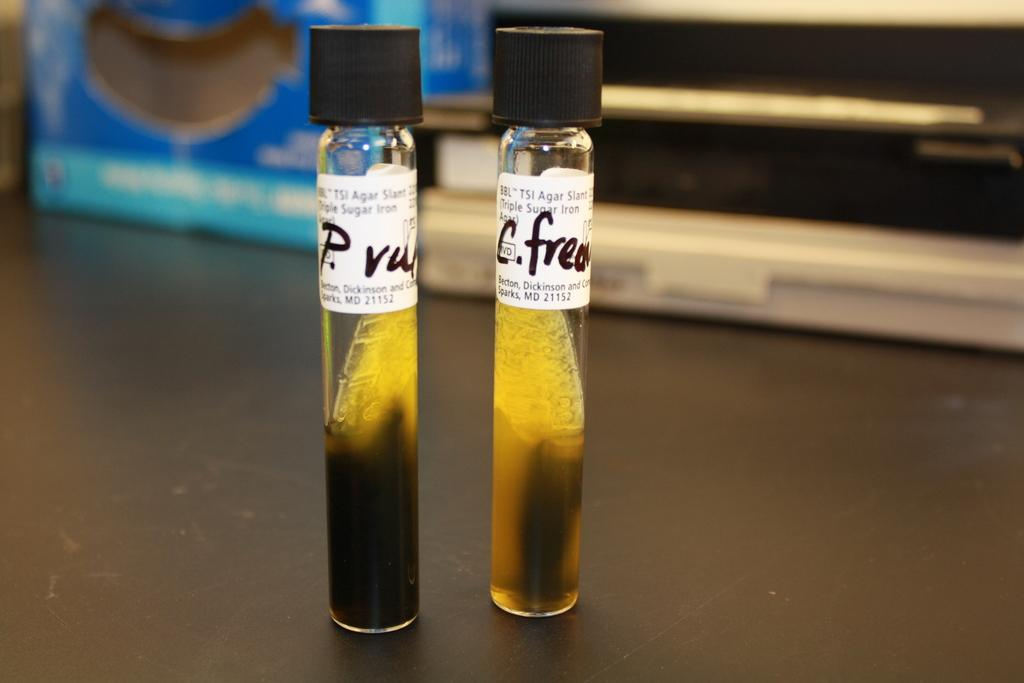<image>
Render a clear and concise summary of the photo. Two medicine vials are labeled with the initials BBL and TSI, among other words. 